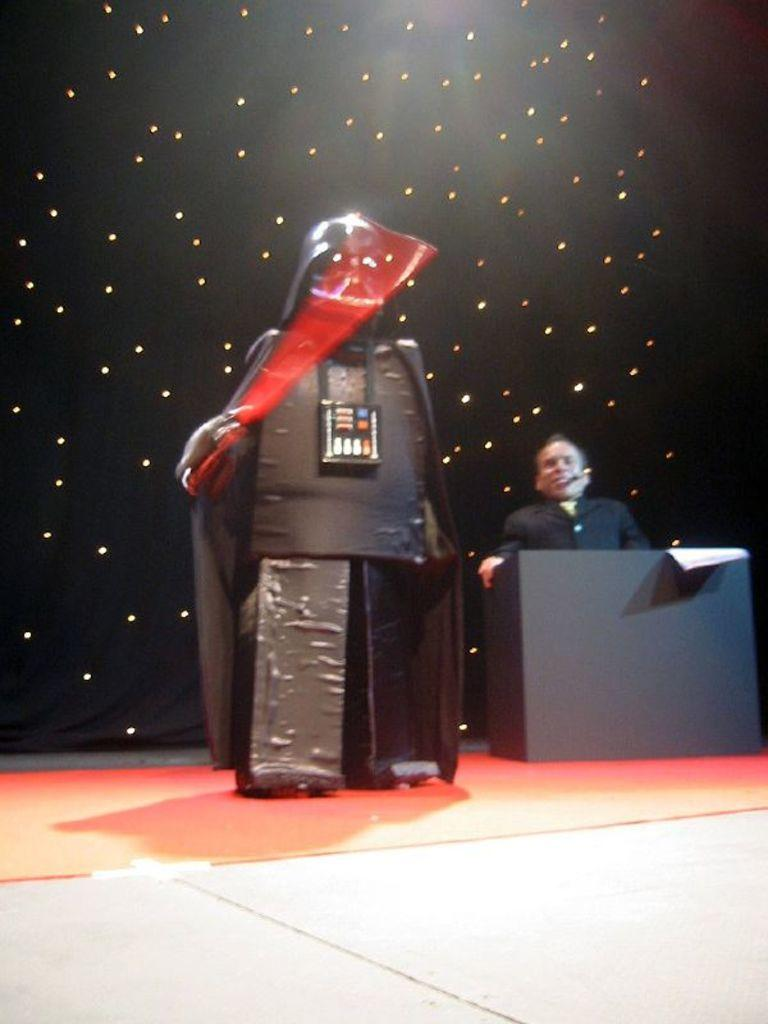Who is present in the image? There is a man in the image. What object can be seen in the image that might be used for writing or reading? There is a paper in the image. What is the statue-like robot doing in the image? The statue-like robot is stationary in the image. What type of surface is visible at the bottom of the image? The floor is visible at the bottom of the image. How would you describe the lighting in the background of the image? The background of the image is dark with some lights. What type of trail can be seen behind the man in the image? There is no trail visible behind the man in the image. 